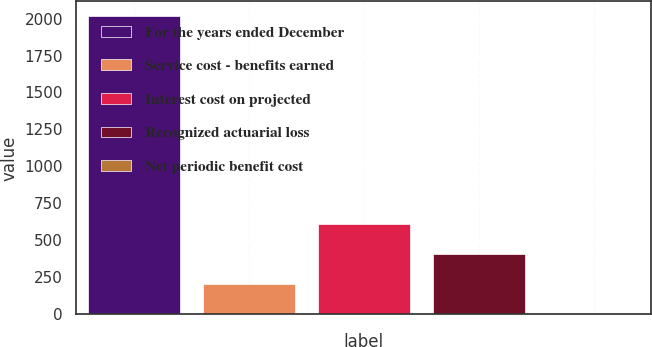Convert chart. <chart><loc_0><loc_0><loc_500><loc_500><bar_chart><fcel>For the years ended December<fcel>Service cost - benefits earned<fcel>Interest cost on projected<fcel>Recognized actuarial loss<fcel>Net periodic benefit cost<nl><fcel>2015<fcel>205.1<fcel>607.3<fcel>406.2<fcel>4<nl></chart> 